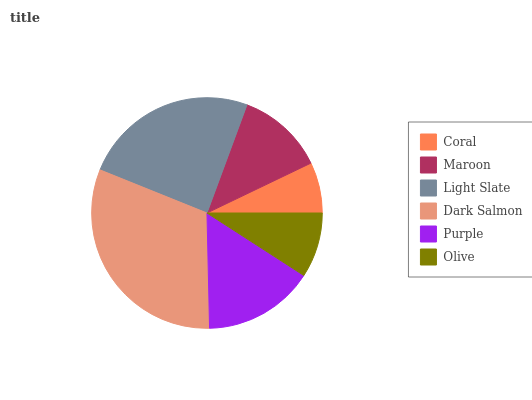Is Coral the minimum?
Answer yes or no. Yes. Is Dark Salmon the maximum?
Answer yes or no. Yes. Is Maroon the minimum?
Answer yes or no. No. Is Maroon the maximum?
Answer yes or no. No. Is Maroon greater than Coral?
Answer yes or no. Yes. Is Coral less than Maroon?
Answer yes or no. Yes. Is Coral greater than Maroon?
Answer yes or no. No. Is Maroon less than Coral?
Answer yes or no. No. Is Purple the high median?
Answer yes or no. Yes. Is Maroon the low median?
Answer yes or no. Yes. Is Light Slate the high median?
Answer yes or no. No. Is Purple the low median?
Answer yes or no. No. 